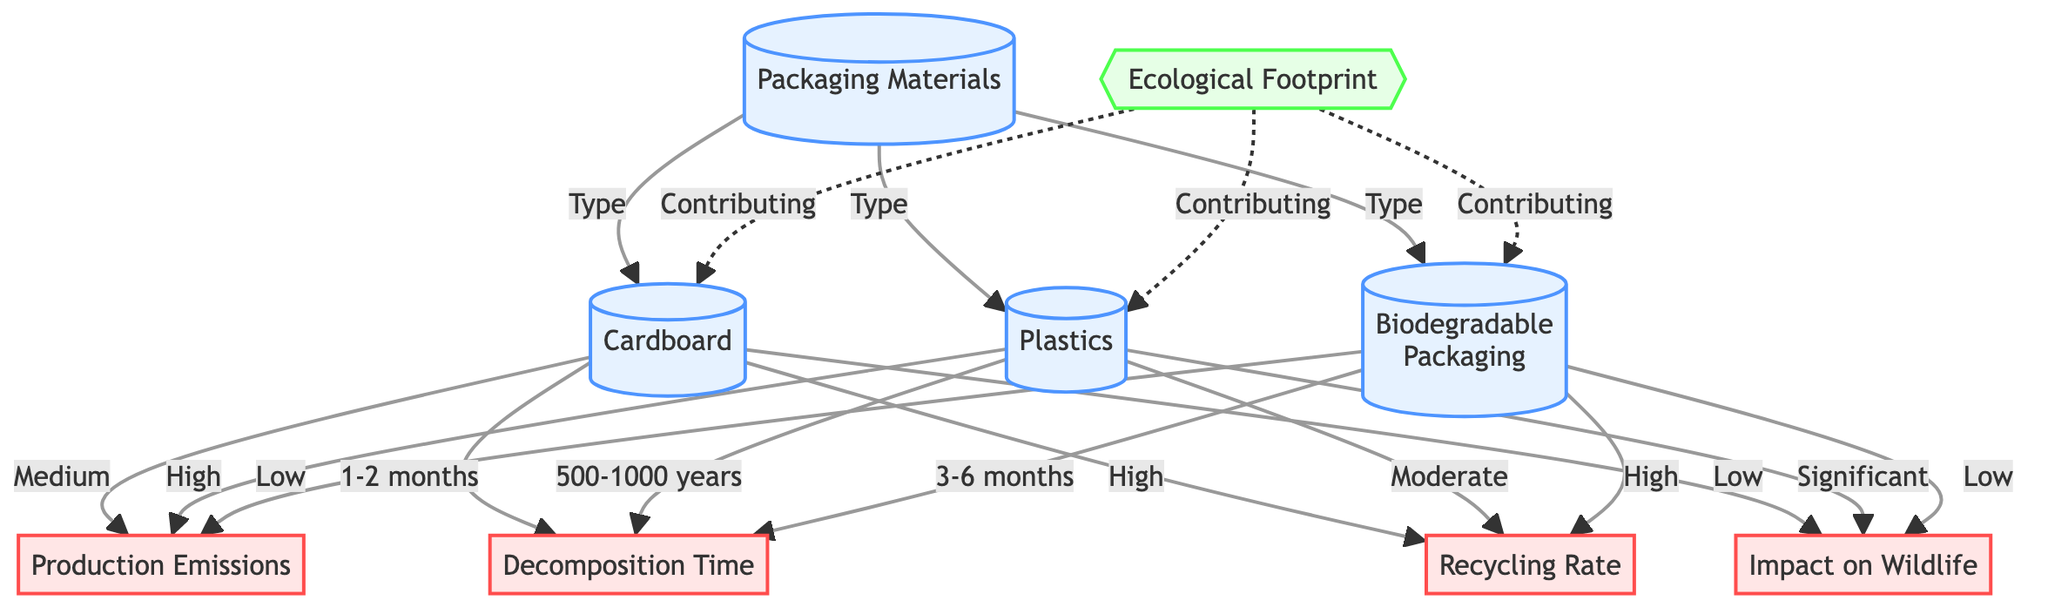What are the three types of packaging materials listed in the diagram? The diagram identifies three types of packaging materials: Cardboard, Plastics, and Biodegradable Packaging, which are denoted as individual nodes connected to the main Packaging Materials node.
Answer: Cardboard, Plastics, Biodegradable Packaging What is the decomposition time for Plastics? The diagram details that Plastics have a decomposition time of 500-1000 years, which is indicated near the Plastics node in the impact section.
Answer: 500-1000 years How many impacts are associated with Cardboard? The diagram shows that the Cardboard node leads to four impacts: Production Emissions, Decomposition Time, Recycling Rate, and Impact on Wildlife, indicating a total of four impacts.
Answer: 4 Which packaging material has the highest production emissions impact? The diagram indicates that Plastics are classified as having "High" production emissions, which deserves attention when considering ecological footprints of various materials.
Answer: High What is the ecological footprint contribution of Biodegradable Packaging? According to the diagram, Biodegradable Packaging contributes to the ecological footprint but has a low impact on Production Emissions, which is specified in the diagram next to its respective node.
Answer: Low Which packaging material has a decomposition time of 1-2 months? The diagram clearly states that Cardboard has a decomposition time of 1-2 months, which is specifically noted next to the Cardboard node under the Decomposition Time impact section.
Answer: 1-2 months Which material has a high recycling rate? The diagram indicates that Biodegradable Packaging has a high recycling rate, denoted in the impact section associated with its node.
Answer: High What is the impact on wildlife for Cardboard? According to the diagram, Cardboard has a low impact on wildlife, as specified in the information beneath the Cardboard node under the Impact on Wildlife section.
Answer: Low 